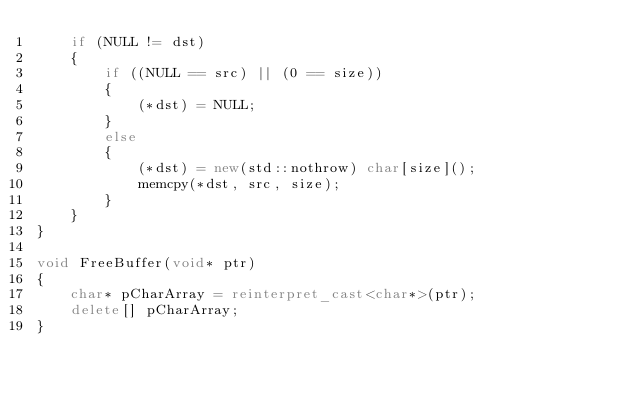Convert code to text. <code><loc_0><loc_0><loc_500><loc_500><_C++_>    if (NULL != dst)
    {
        if ((NULL == src) || (0 == size))
        {
            (*dst) = NULL;
        }
        else
        {
            (*dst) = new(std::nothrow) char[size]();
            memcpy(*dst, src, size);
        }
    }
}

void FreeBuffer(void* ptr)
{
    char* pCharArray = reinterpret_cast<char*>(ptr);
    delete[] pCharArray;
}
</code> 